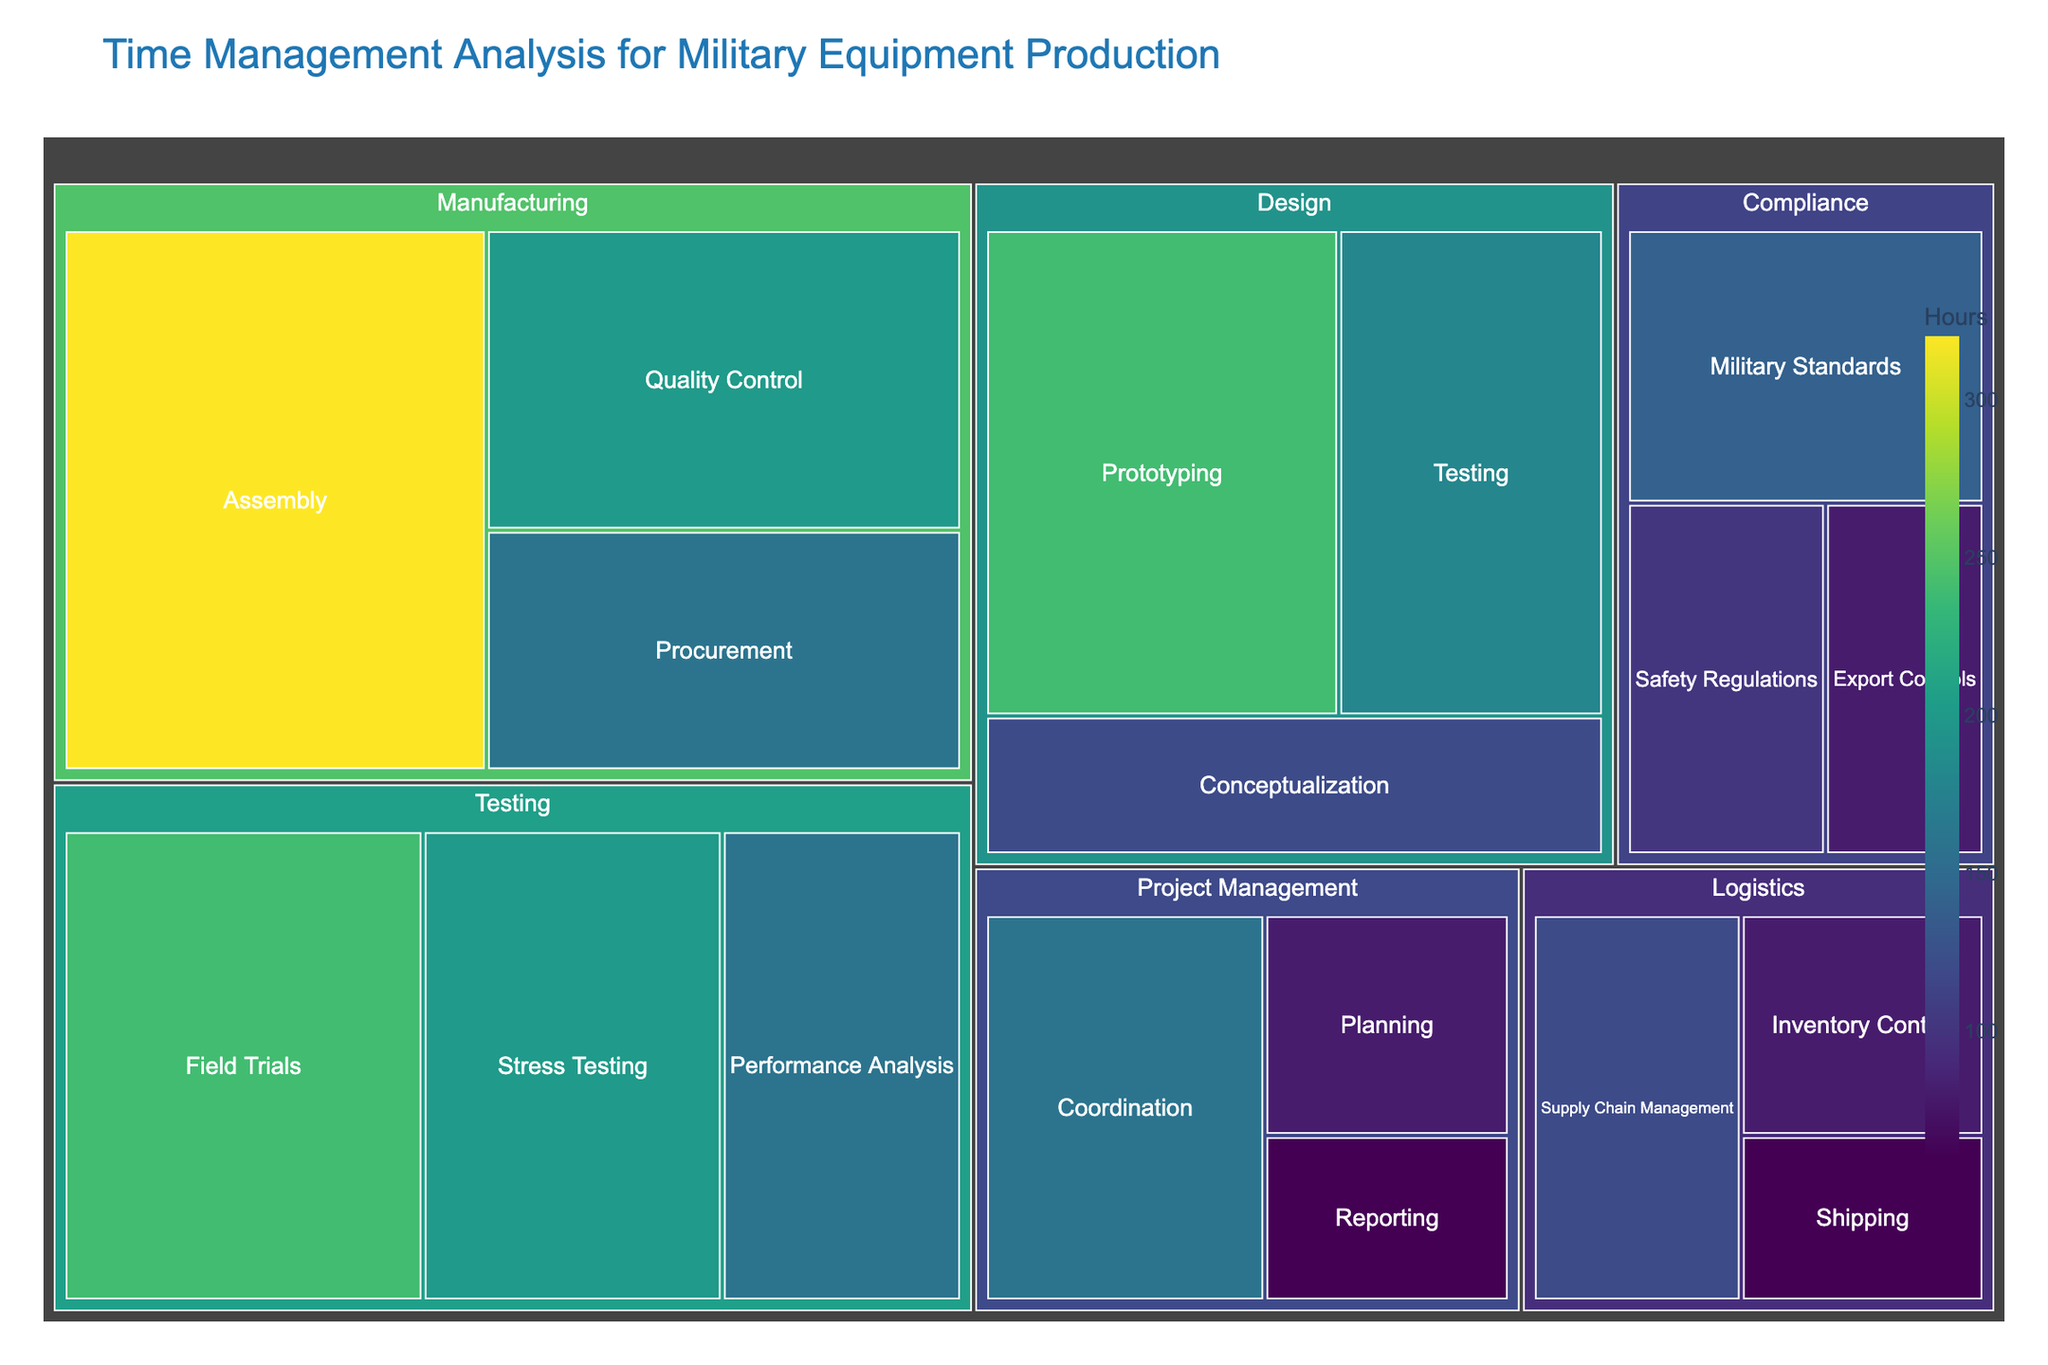What's the title of the Treemap? The title of the Treemap is usually prominently displayed at the top and it helps the viewer understand the purpose of the chart.
Answer: Time Management Analysis for Military Equipment Production Which subcategory in the 'Testing' category takes the most time? By looking at the subcategories under 'Testing', we identify the one with the largest block. 'Field Trials' has more hours than the others.
Answer: Field Trials How many hours are spent on 'Project Management' in total? We sum the time values for all the subcategories under 'Project Management'. Planning (80) + Coordination (160) + Reporting (60) = 300 hours
Answer: 300 hours Which category occupies the most time overall? By summing up the hours for each category and comparing, we find that 'Manufacturing' has the highest total.
Answer: Manufacturing How does the time spent on 'Prototyping' compare to 'Assembly'? Compare the sizes of the subcategories; 'Prototyping' takes 240 hours while 'Assembly' takes 320 hours, so 'Assembly' takes more time.
Answer: Assembly takes more time What is the difference in time between 'Stress Testing' and 'Inventory Control'? Subtract the hours for 'Inventory Control' (80) from 'Stress Testing' (200): 200 - 80 = 120 hours
Answer: 120 hours Which category has the smallest total time, and what are its subcategories? Calculate the total time for each category and identify the smallest one. Here, 'Compliance' has the least time with Safety Regulations (100), Export Controls (80), and Military Standards (140), summing up to 320 hours.
Answer: Compliance: Safety Regulations, Export Controls, Military Standards What's the average time spent on all the subcategories within 'Logistics'? Sum the hours and divide by the number of subcategories in 'Logistics'. (120 + 80 + 60) / 3 = 260 / 3 ≈ 87 hours
Answer: 87 hours Which subcategory under 'Design' occupies the least time? By looking at the blocks under 'Design', we see that 'Conceptualization' at 120 hours is the least compared to the other subcategories.
Answer: Conceptualization Is more time spent on 'Quality Control' or 'Performance Analysis'? Compare the hours directly; 'Quality Control' has 200 hours and 'Performance Analysis' has 160 hours. 'Quality Control' takes more time.
Answer: Quality Control 